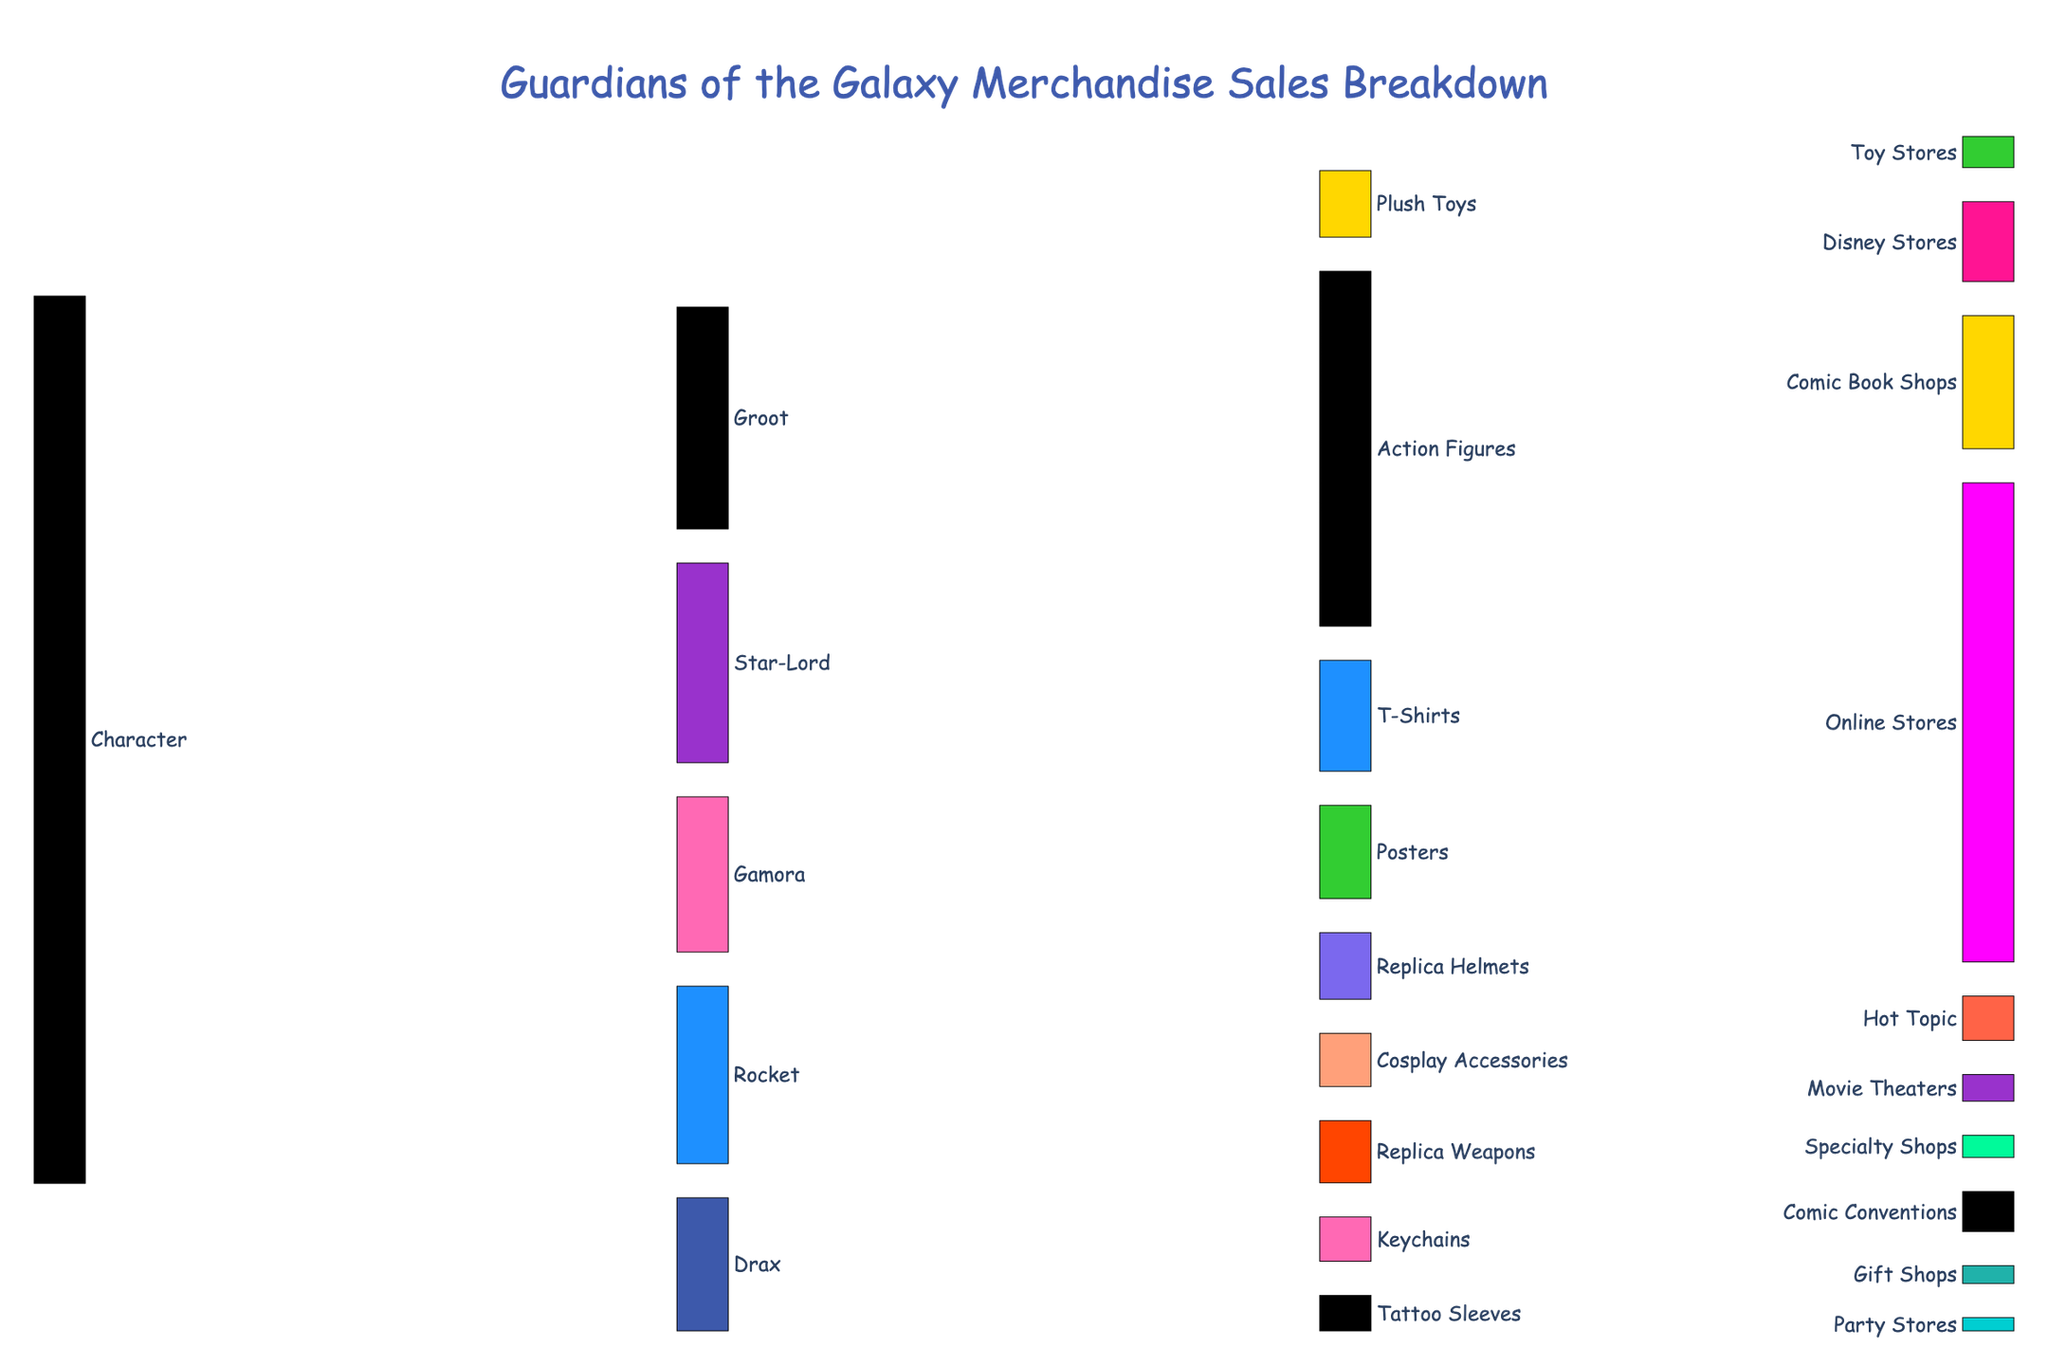What's the main title of the figure? The title of the figure is displayed at the top in bold and large font. It helps to quickly understand what the visual representation is about.
Answer: Guardians of the Galaxy Merchandise Sales Breakdown Which character has the highest merchandise sales value? By looking at the width of the first layer of links from 'Character', the one leading to 'Groot' is the widest, indicating that Groot has the highest merchandise sales value.
Answer: Groot How many sales channels are there for Action Figures? In the Sankey diagram, you trace the line from 'Action Figures' to its targets and count the unique destinations. There are three targets: Online Stores, Comic Book Shops, and Disney Stores.
Answer: Three What is the combined sales value for Star-Lord's merchandise? Sum the values leading from 'Star-Lord' to its respective merchandise categories: Action Figures (1800), Replica Helmets (1500), and Posters (1200). Their total is 1800 + 1500 + 1200 = 4500.
Answer: 4500 Do Gamora and Rocket have more sales in common items or separate items? Comparing their individual links shows that both have sales in 'Action Figures' and 'Posters', while Gamora has additional sales in 'Cosplay Accessories' and Rocket in 'Replica Weapons' and 'Keychains'. Gamora and Rocket share 2 items out of their respective 3 and 4 items.
Answer: Separate items Which character contributes the least to T-Shirt sales? By looking at the links from 'T-Shirts', 'Groot' leads to T-Shirts with 1500 and 'Drax' with 1000. Groot is the only character linked to shirts.
Answer: Groot Which sales channel contributes the most to Online Stores? Summing up all sales values linked to 'Online Stores' and comparing the categories will tell you which one has the highest. 'Action Figures' is the highest with 4000.
Answer: Action Figures Between Replica Helmets and Replica Weapons, which category has higher total sales and by how much? Add up the contributing values for 'Replica Helmets' (Online Stores: 1000, Specialty Shops: 500) and 'Replica Weapons' (Online Stores: 900, Comic Conventions: 500) and compare them. Replica Helmets = 1500, Replica Weapons = 1400, causing a difference of 1500 - 1400 = 100.
Answer: Replica Helmets by 100 Which category does Drax have no contribution to? By observing the links from 'Drax', the character links to 'Action Figures', 'T-Shirts', and 'Tattoo Sleeves'. 'Posters' is a category with no link from 'Drax'.
Answer: Posters 